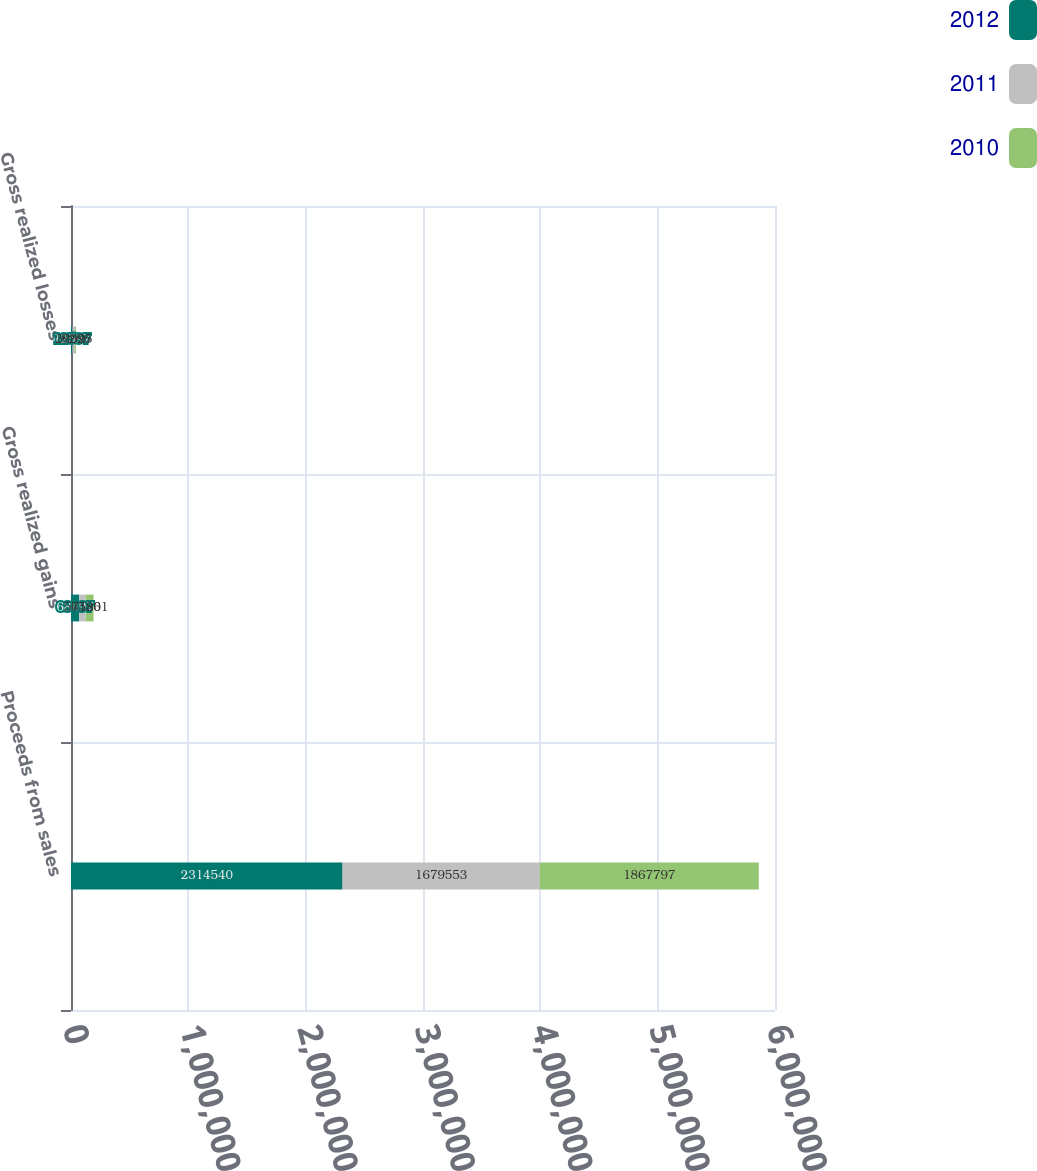<chart> <loc_0><loc_0><loc_500><loc_500><stacked_bar_chart><ecel><fcel>Proceeds from sales<fcel>Gross realized gains<fcel>Gross realized losses<nl><fcel>2012<fcel>2.31454e+06<fcel>68697<fcel>12597<nl><fcel>2011<fcel>1.67955e+06<fcel>57120<fcel>20925<nl><fcel>2010<fcel>1.8678e+06<fcel>65861<fcel>8286<nl></chart> 